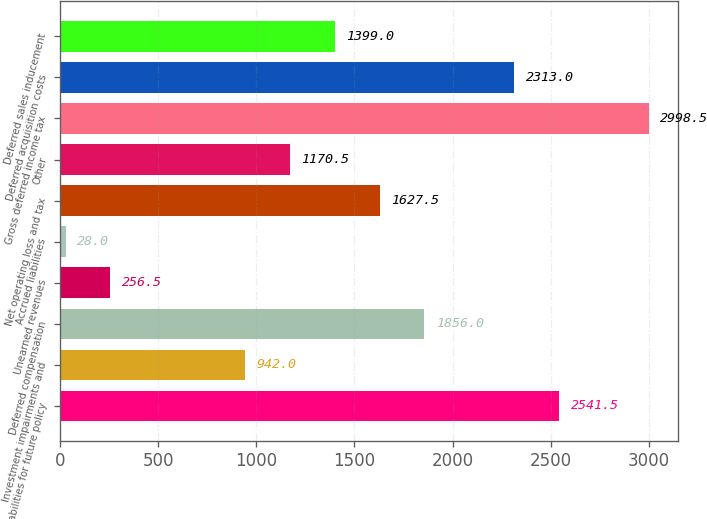<chart> <loc_0><loc_0><loc_500><loc_500><bar_chart><fcel>Liabilities for future policy<fcel>Investment impairments and<fcel>Deferred compensation<fcel>Unearned revenues<fcel>Accrued liabilities<fcel>Net operating loss and tax<fcel>Other<fcel>Gross deferred income tax<fcel>Deferred acquisition costs<fcel>Deferred sales inducement<nl><fcel>2541.5<fcel>942<fcel>1856<fcel>256.5<fcel>28<fcel>1627.5<fcel>1170.5<fcel>2998.5<fcel>2313<fcel>1399<nl></chart> 